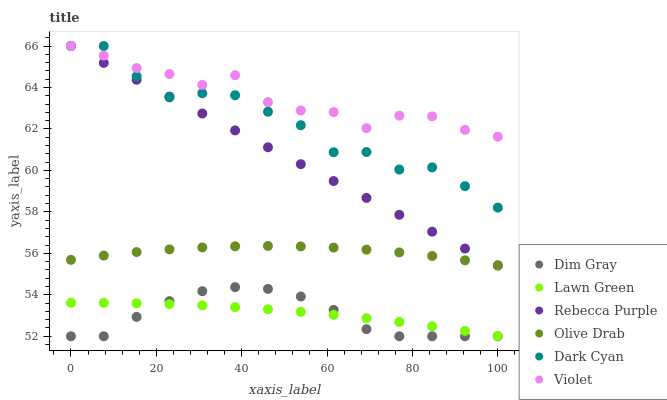Does Dim Gray have the minimum area under the curve?
Answer yes or no. Yes. Does Violet have the maximum area under the curve?
Answer yes or no. Yes. Does Rebecca Purple have the minimum area under the curve?
Answer yes or no. No. Does Rebecca Purple have the maximum area under the curve?
Answer yes or no. No. Is Rebecca Purple the smoothest?
Answer yes or no. Yes. Is Dark Cyan the roughest?
Answer yes or no. Yes. Is Dim Gray the smoothest?
Answer yes or no. No. Is Dim Gray the roughest?
Answer yes or no. No. Does Dim Gray have the lowest value?
Answer yes or no. Yes. Does Rebecca Purple have the lowest value?
Answer yes or no. No. Does Dark Cyan have the highest value?
Answer yes or no. Yes. Does Dim Gray have the highest value?
Answer yes or no. No. Is Lawn Green less than Olive Drab?
Answer yes or no. Yes. Is Violet greater than Dim Gray?
Answer yes or no. Yes. Does Dark Cyan intersect Rebecca Purple?
Answer yes or no. Yes. Is Dark Cyan less than Rebecca Purple?
Answer yes or no. No. Is Dark Cyan greater than Rebecca Purple?
Answer yes or no. No. Does Lawn Green intersect Olive Drab?
Answer yes or no. No. 